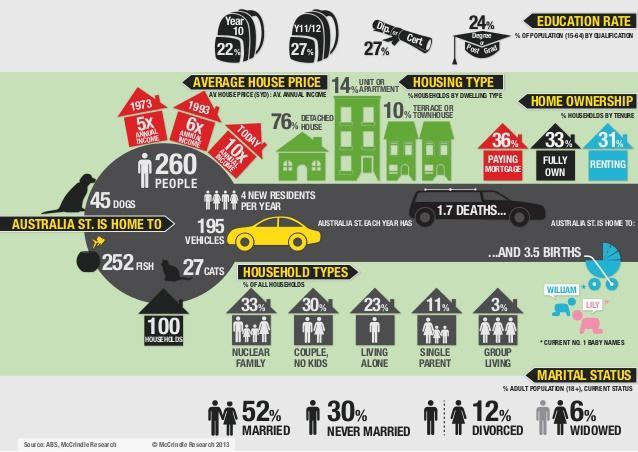Which household type has the lowest percentage?
Answer the question with a short phrase. Group living What is the current no.1 baby name for boys? William What is the percentage of households of the type nuclear family? 33% What percentage of adult population is divorced? 12 What percentage of housing types are not Detached houses? 24 What percentage of households are fully owned? 33% What percentage of population have a degree or Post graduation? 24 What is the current no.1 baby name for girls? Lily 